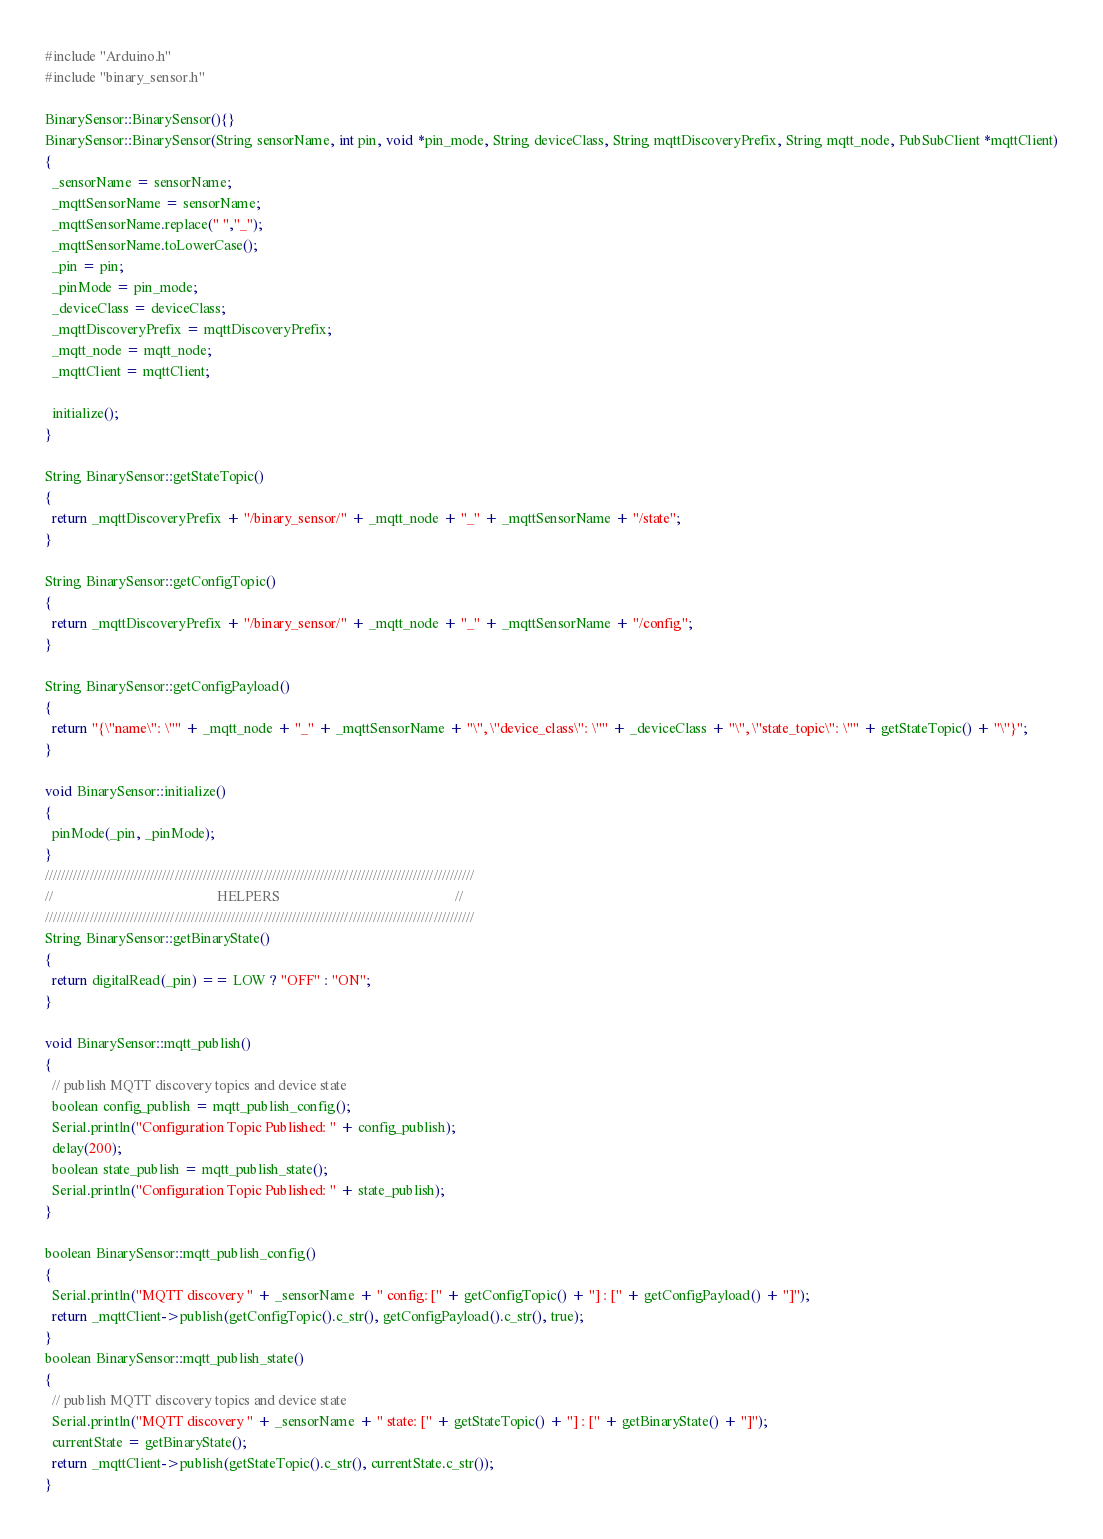<code> <loc_0><loc_0><loc_500><loc_500><_C++_>#include "Arduino.h"
#include "binary_sensor.h"

BinarySensor::BinarySensor(){}
BinarySensor::BinarySensor(String sensorName, int pin, void *pin_mode, String deviceClass, String mqttDiscoveryPrefix, String mqtt_node, PubSubClient *mqttClient)
{
  _sensorName = sensorName;
  _mqttSensorName = sensorName;
  _mqttSensorName.replace(" ","_");
  _mqttSensorName.toLowerCase();
  _pin = pin;
  _pinMode = pin_mode;
  _deviceClass = deviceClass;
  _mqttDiscoveryPrefix = mqttDiscoveryPrefix;
  _mqtt_node = mqtt_node;
  _mqttClient = mqttClient;
  
  initialize();
}

String BinarySensor::getStateTopic()
{
  return _mqttDiscoveryPrefix + "/binary_sensor/" + _mqtt_node + "_" + _mqttSensorName + "/state";
}

String BinarySensor::getConfigTopic()
{
  return _mqttDiscoveryPrefix + "/binary_sensor/" + _mqtt_node + "_" + _mqttSensorName + "/config";
}

String BinarySensor::getConfigPayload()
{
  return "{\"name\": \"" + _mqtt_node + "_" + _mqttSensorName + "\", \"device_class\": \"" + _deviceClass + "\", \"state_topic\": \"" + getStateTopic() + "\"}";
}

void BinarySensor::initialize()
{
  pinMode(_pin, _pinMode);
}
//////////////////////////////////////////////////////////////////////////////////////////////////////////
//                                              HELPERS                                                 //
//////////////////////////////////////////////////////////////////////////////////////////////////////////
String BinarySensor::getBinaryState()
{
  return digitalRead(_pin) == LOW ? "OFF" : "ON";
}

void BinarySensor::mqtt_publish()
{
  // publish MQTT discovery topics and device state
  boolean config_publish = mqtt_publish_config();
  Serial.println("Configuration Topic Published: " + config_publish);
  delay(200);
  boolean state_publish = mqtt_publish_state();
  Serial.println("Configuration Topic Published: " + state_publish);
}

boolean BinarySensor::mqtt_publish_config()
{
  Serial.println("MQTT discovery " + _sensorName + " config: [" + getConfigTopic() + "] : [" + getConfigPayload() + "]");
  return _mqttClient->publish(getConfigTopic().c_str(), getConfigPayload().c_str(), true);
}
boolean BinarySensor::mqtt_publish_state()
{
  // publish MQTT discovery topics and device state
  Serial.println("MQTT discovery " + _sensorName + " state: [" + getStateTopic() + "] : [" + getBinaryState() + "]");
  currentState = getBinaryState();
  return _mqttClient->publish(getStateTopic().c_str(), currentState.c_str());
}
</code> 